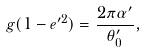Convert formula to latex. <formula><loc_0><loc_0><loc_500><loc_500>g ( 1 - e ^ { \prime 2 } ) = \frac { 2 \pi \alpha ^ { \prime } } { \theta ^ { \prime } _ { 0 } } ,</formula> 